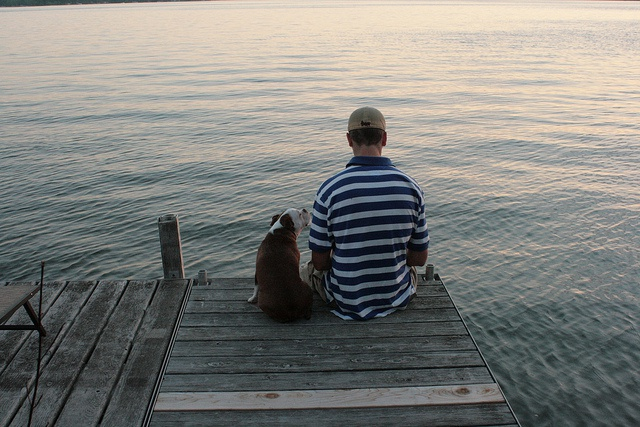Describe the objects in this image and their specific colors. I can see people in purple, black, gray, and navy tones and dog in purple, black, gray, and darkgray tones in this image. 